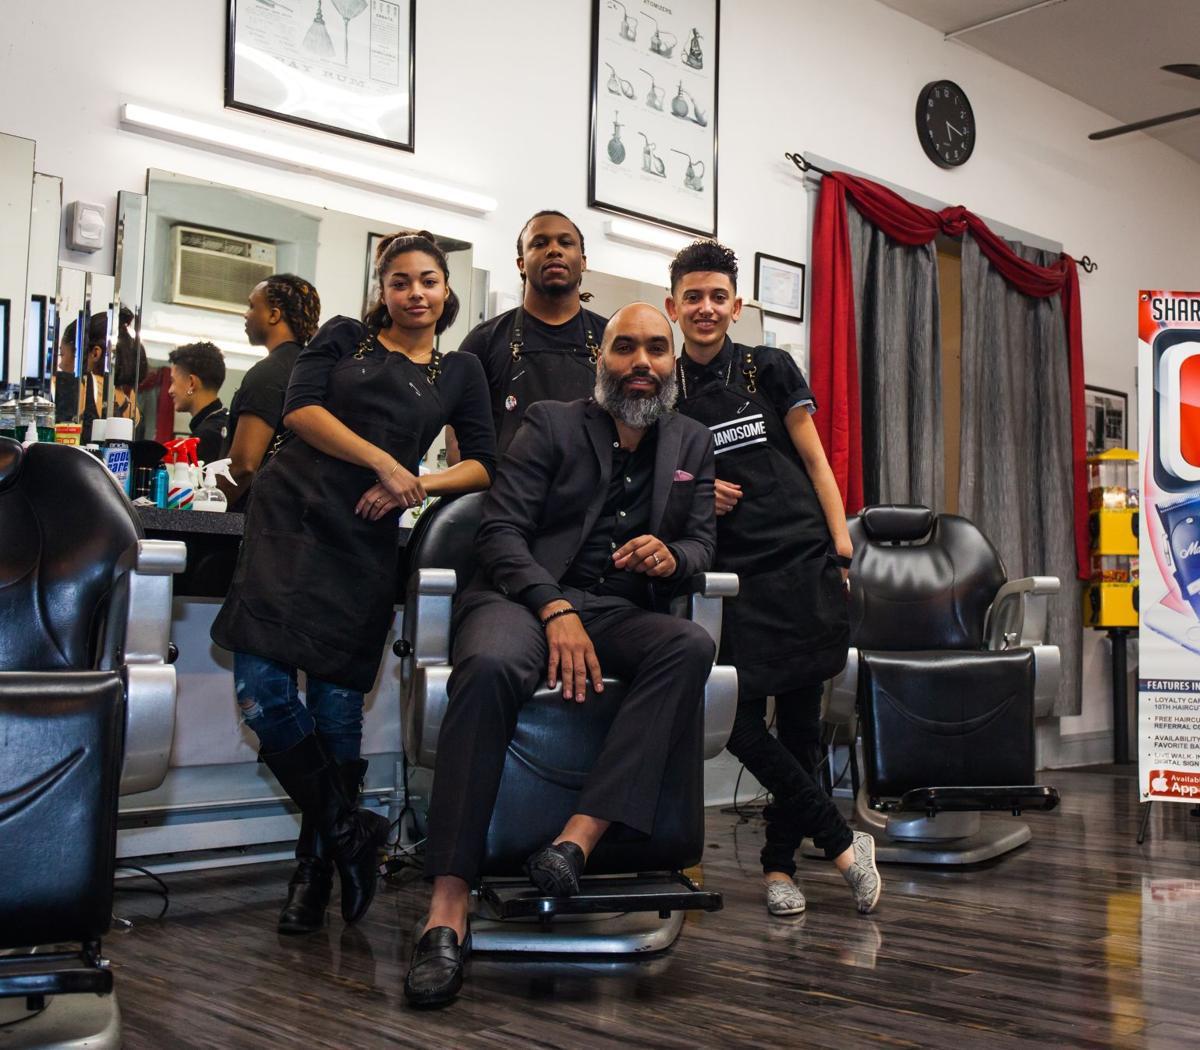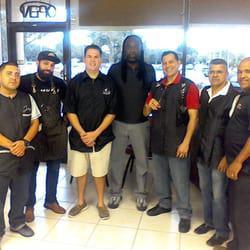The first image is the image on the left, the second image is the image on the right. Evaluate the accuracy of this statement regarding the images: "In the center of one of the images there is a man with a beard sitting in a barber's chair surrounded by people.". Is it true? Answer yes or no. Yes. The first image is the image on the left, the second image is the image on the right. Examine the images to the left and right. Is the description "In at least one image there are four people in black shirts." accurate? Answer yes or no. Yes. 